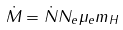Convert formula to latex. <formula><loc_0><loc_0><loc_500><loc_500>\dot { M } = \dot { N } N _ { e } \mu _ { e } m _ { H }</formula> 